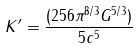<formula> <loc_0><loc_0><loc_500><loc_500>K ^ { \prime } = \frac { ( 2 5 6 \pi ^ { 8 / 3 } G ^ { 5 / 3 } ) } { 5 c ^ { 5 } }</formula> 